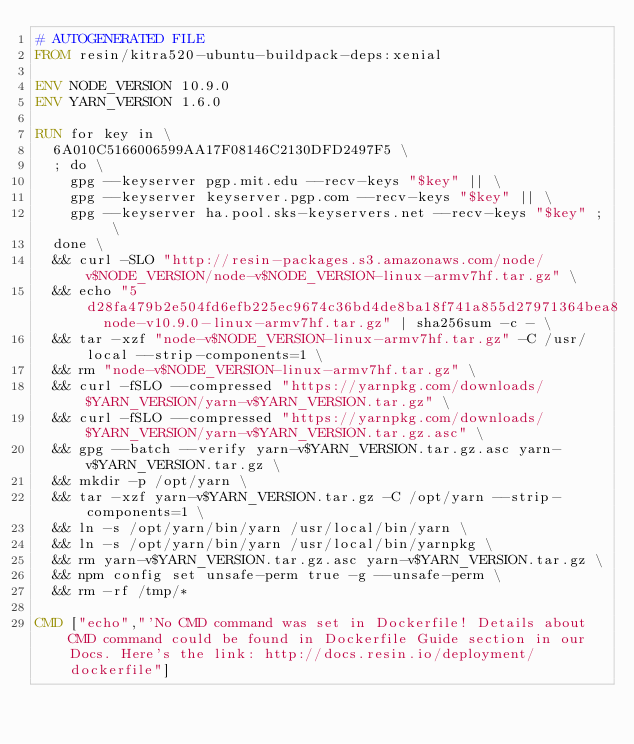<code> <loc_0><loc_0><loc_500><loc_500><_Dockerfile_># AUTOGENERATED FILE
FROM resin/kitra520-ubuntu-buildpack-deps:xenial

ENV NODE_VERSION 10.9.0
ENV YARN_VERSION 1.6.0

RUN for key in \
	6A010C5166006599AA17F08146C2130DFD2497F5 \
	; do \
		gpg --keyserver pgp.mit.edu --recv-keys "$key" || \
		gpg --keyserver keyserver.pgp.com --recv-keys "$key" || \
		gpg --keyserver ha.pool.sks-keyservers.net --recv-keys "$key" ; \
	done \
	&& curl -SLO "http://resin-packages.s3.amazonaws.com/node/v$NODE_VERSION/node-v$NODE_VERSION-linux-armv7hf.tar.gz" \
	&& echo "5d28fa479b2e504fd6efb225ec9674c36bd4de8ba18f741a855d27971364bea8  node-v10.9.0-linux-armv7hf.tar.gz" | sha256sum -c - \
	&& tar -xzf "node-v$NODE_VERSION-linux-armv7hf.tar.gz" -C /usr/local --strip-components=1 \
	&& rm "node-v$NODE_VERSION-linux-armv7hf.tar.gz" \
	&& curl -fSLO --compressed "https://yarnpkg.com/downloads/$YARN_VERSION/yarn-v$YARN_VERSION.tar.gz" \
	&& curl -fSLO --compressed "https://yarnpkg.com/downloads/$YARN_VERSION/yarn-v$YARN_VERSION.tar.gz.asc" \
	&& gpg --batch --verify yarn-v$YARN_VERSION.tar.gz.asc yarn-v$YARN_VERSION.tar.gz \
	&& mkdir -p /opt/yarn \
	&& tar -xzf yarn-v$YARN_VERSION.tar.gz -C /opt/yarn --strip-components=1 \
	&& ln -s /opt/yarn/bin/yarn /usr/local/bin/yarn \
	&& ln -s /opt/yarn/bin/yarn /usr/local/bin/yarnpkg \
	&& rm yarn-v$YARN_VERSION.tar.gz.asc yarn-v$YARN_VERSION.tar.gz \
	&& npm config set unsafe-perm true -g --unsafe-perm \
	&& rm -rf /tmp/*

CMD ["echo","'No CMD command was set in Dockerfile! Details about CMD command could be found in Dockerfile Guide section in our Docs. Here's the link: http://docs.resin.io/deployment/dockerfile"]
</code> 